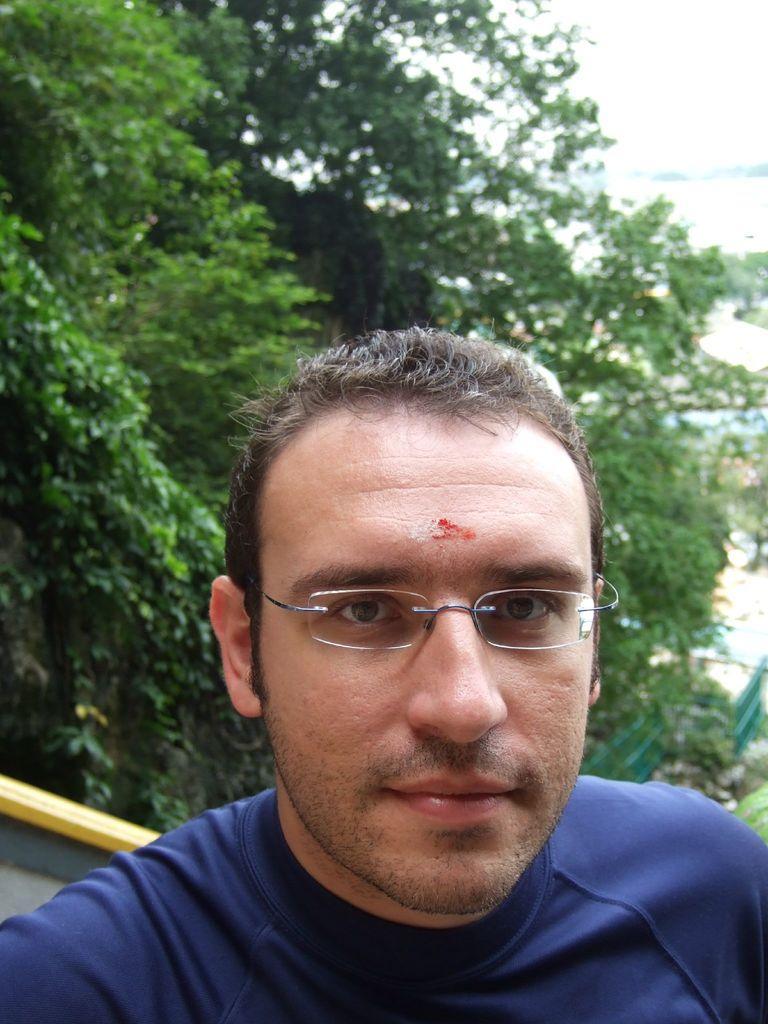Describe this image in one or two sentences. In the center of the image, we can see a man wearing glasses and in the background, there are trees. 